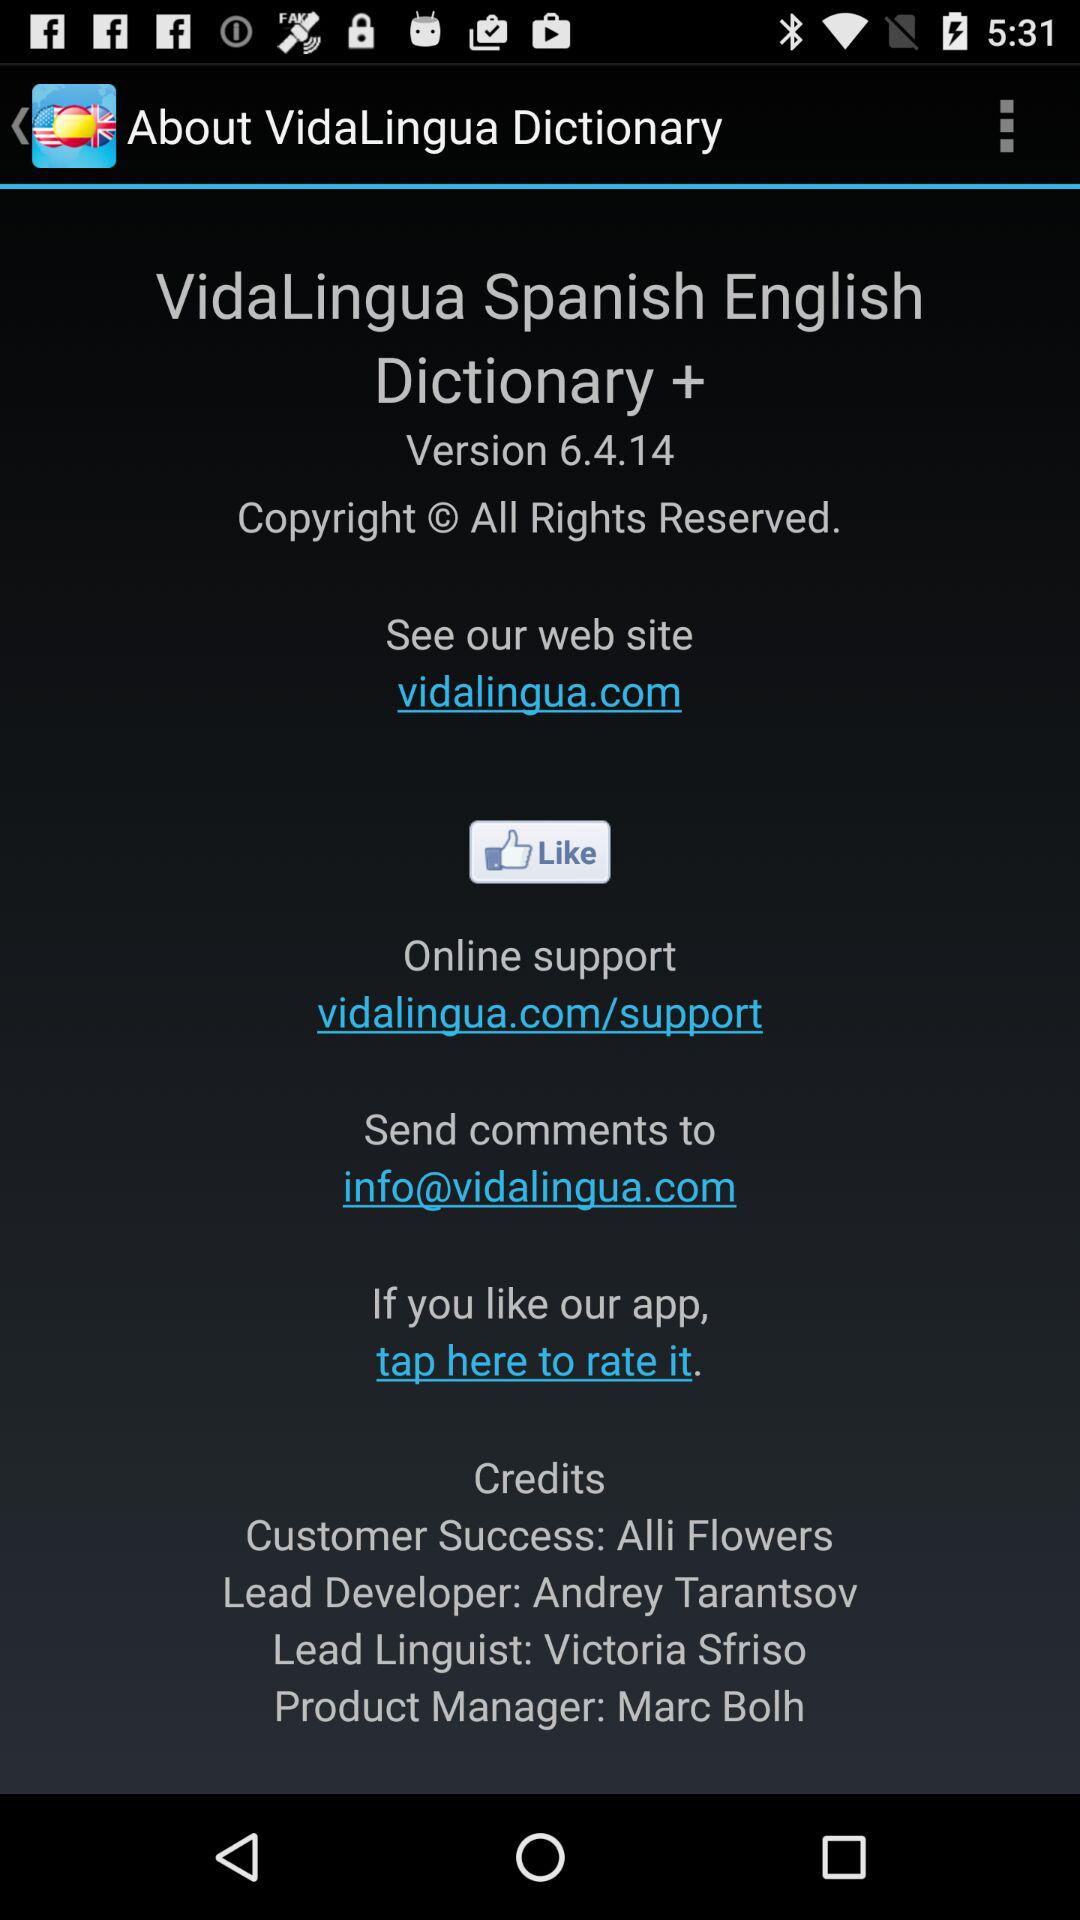What is the online support contact address? The online support contact address is vidalingua.com/support. 